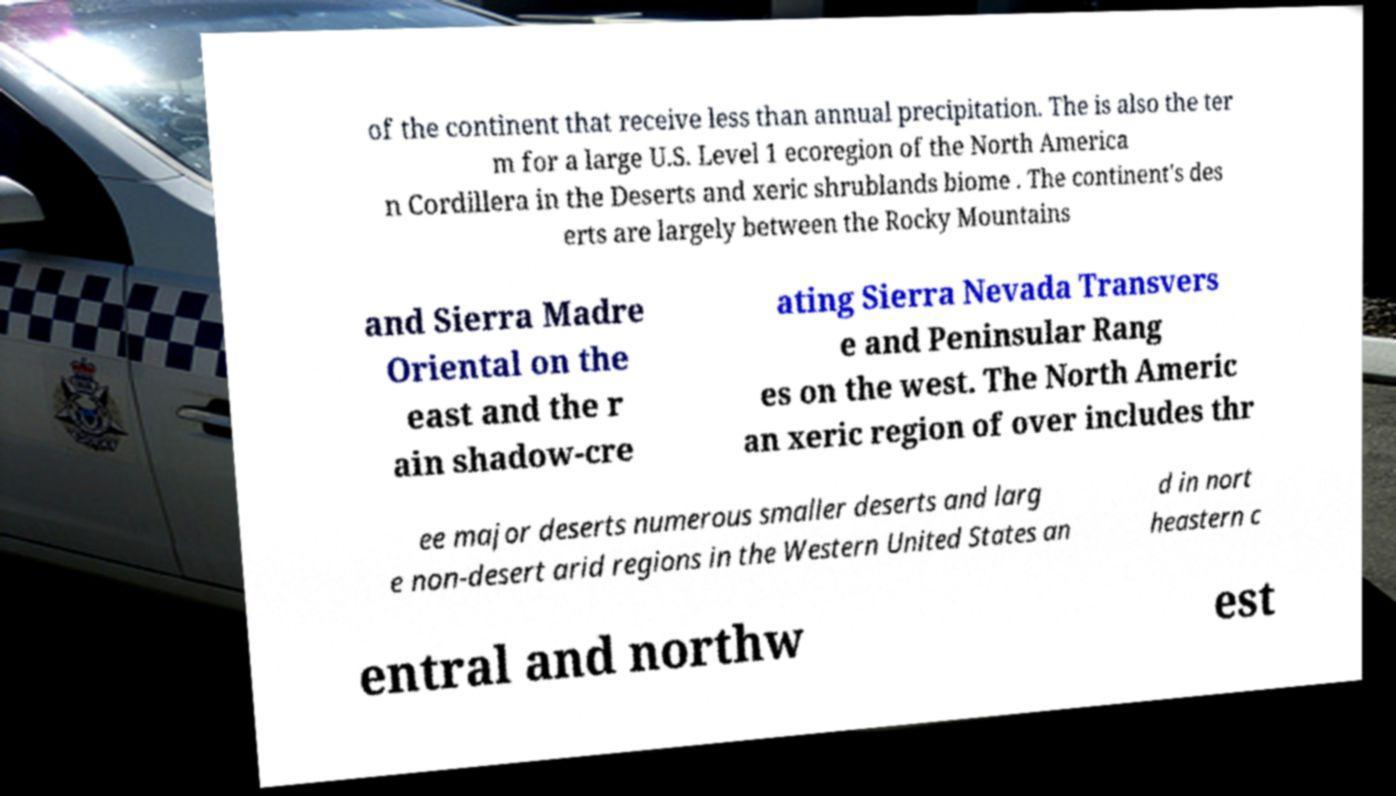Could you extract and type out the text from this image? of the continent that receive less than annual precipitation. The is also the ter m for a large U.S. Level 1 ecoregion of the North America n Cordillera in the Deserts and xeric shrublands biome . The continent's des erts are largely between the Rocky Mountains and Sierra Madre Oriental on the east and the r ain shadow-cre ating Sierra Nevada Transvers e and Peninsular Rang es on the west. The North Americ an xeric region of over includes thr ee major deserts numerous smaller deserts and larg e non-desert arid regions in the Western United States an d in nort heastern c entral and northw est 